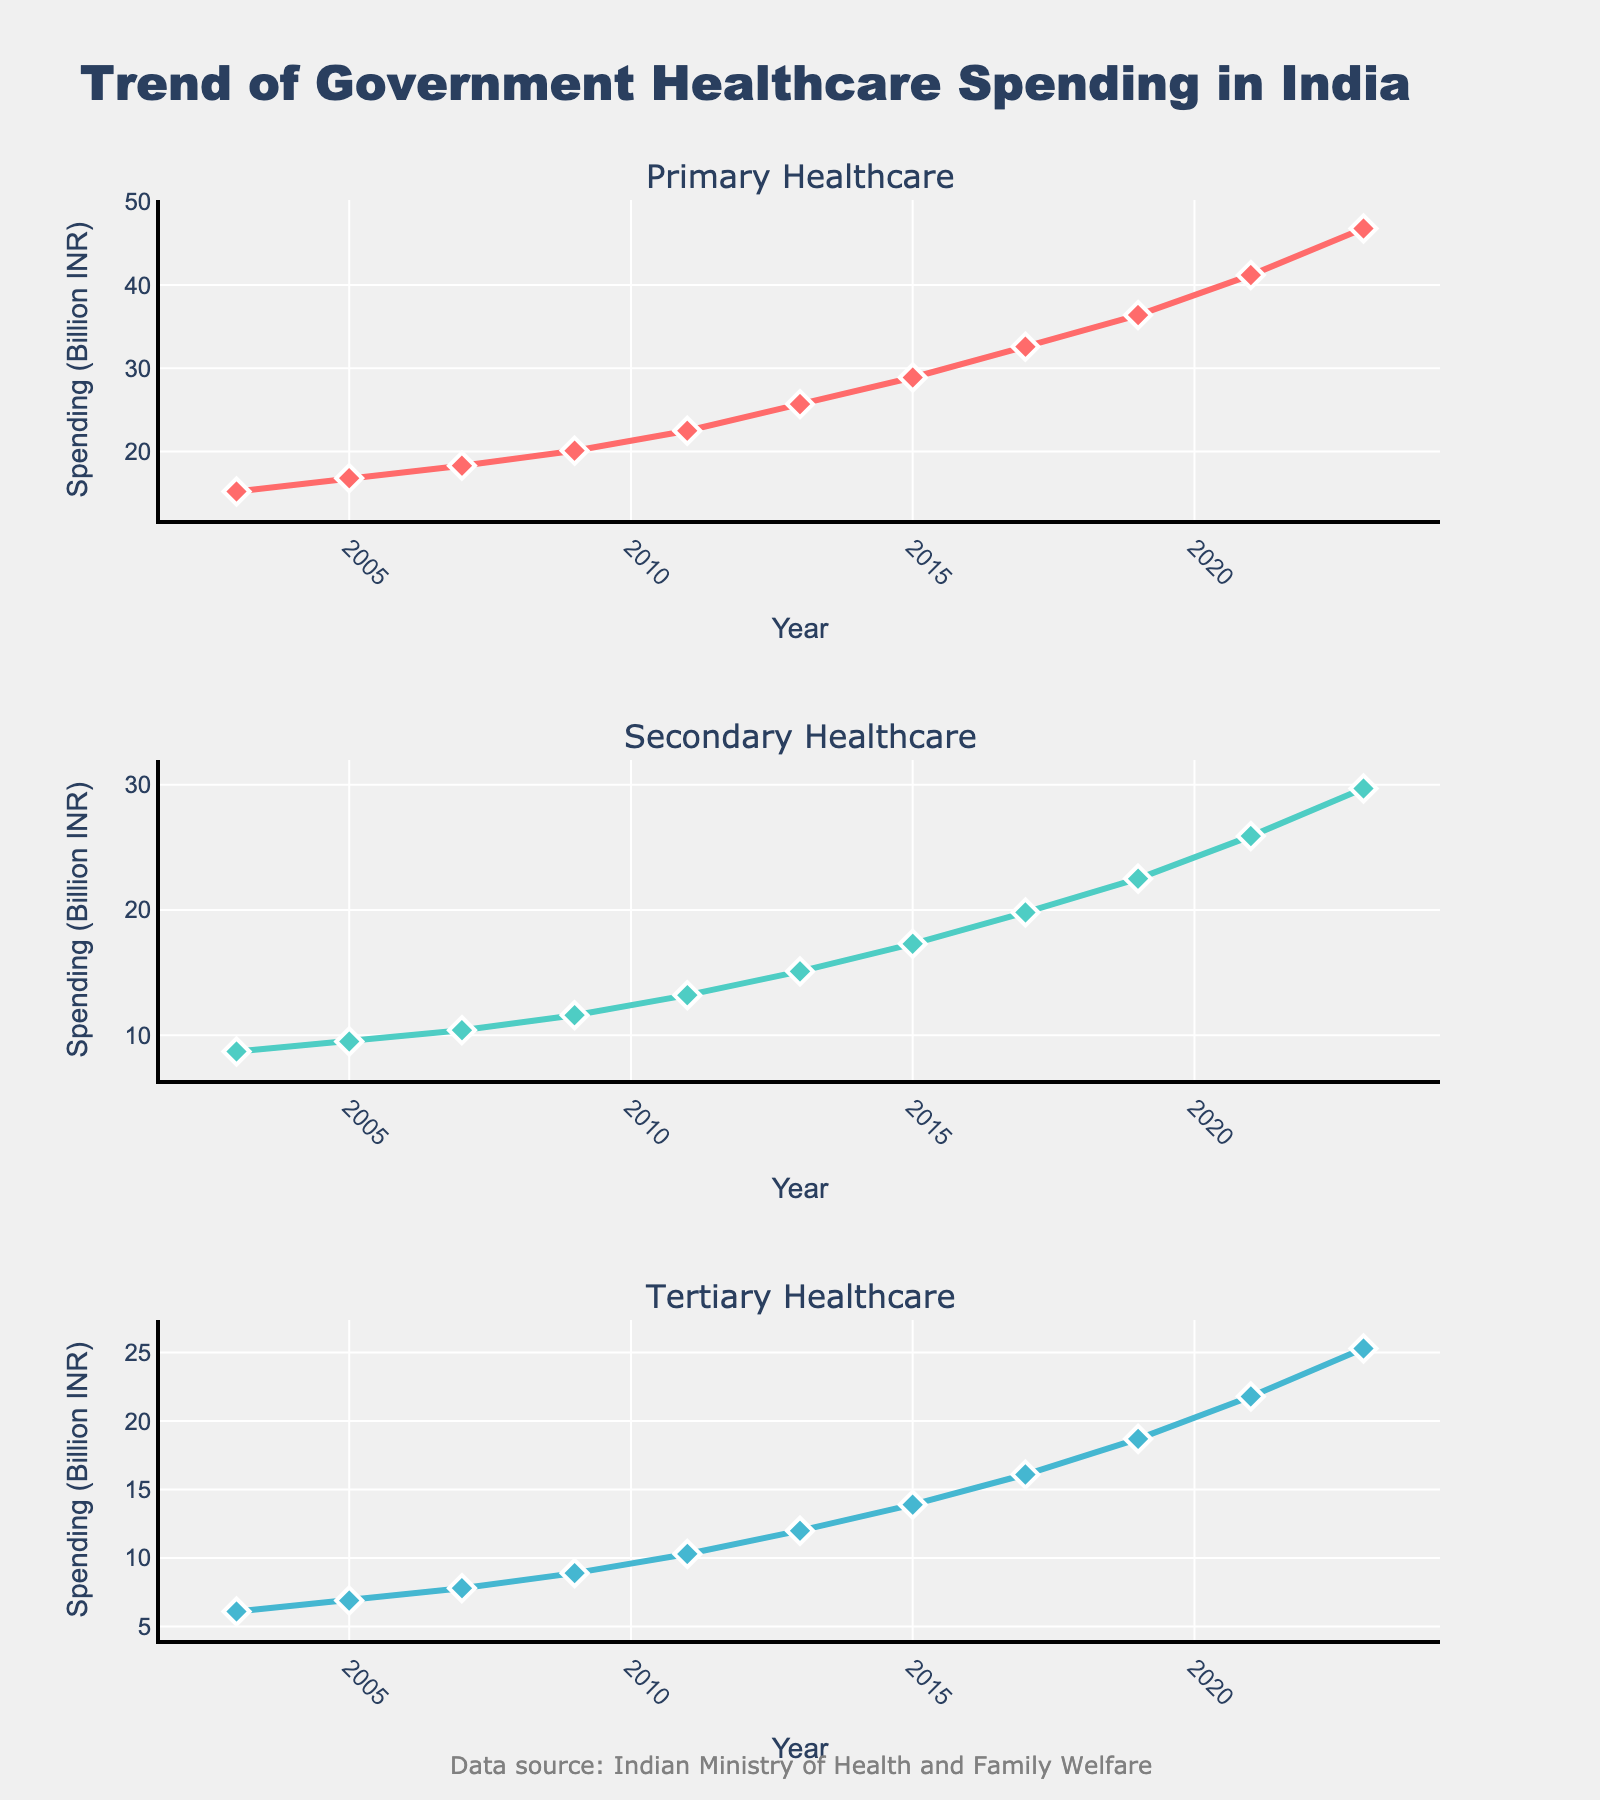Which healthcare sector had the highest spending in 2023? In the subplot for 2023, the "Primary Healthcare" sector shows the highest spending value among the three sectors.
Answer: Primary Healthcare What is the title of the figure? The title of the figure is displayed prominently at the top of the plot.
Answer: Trend of Government Healthcare Spending in India Between 2003 and 2023, by how much did the spending on Secondary Healthcare increase? To find the increase, subtract the spending in 2003 from the spending in 2023 for Secondary Healthcare: 29.7 - 8.7 = 21.
Answer: 21 (Billion INR) Which year shows the sharpest increase in spending across all healthcare sectors? To identify the sharpest increase, observe the slopes of the lines across all three healthcare sectors. The years 2019 to 2021 show a notable increase for all sectors.
Answer: 2019 to 2021 How does the trend of Tertiary Healthcare spending compare to that of Primary Healthcare over the 20 years? The plot shows that both have an upward trend; however, Primary Healthcare increases more steeply compared to Tertiary Healthcare.
Answer: Primary Healthcare increased more steeply What are the colors used for the lines representing the healthcare sectors, and which sector does each color represent? By looking at the lines, the colors are pink, green, and blue for Primary, Secondary, and Tertiary Healthcare, respectively.
Answer: Pink: Primary Healthcare; Green: Secondary Healthcare; Blue: Tertiary Healthcare What is the average government spending on Primary Healthcare over the 20 years? Calculate the average by summing the spending values for Primary Healthcare from 2003 to 2023 and dividing by the number of years. The sum is (15.2 + 16.8 + 18.3 + 20.1 + 22.5 + 25.7 + 28.9 + 32.6 + 36.4 + 41.2 + 46.8) = 304.5. The average is 304.5 / 11 ≈ 27.68.
Answer: 27.68 (Billion INR) Which healthcare sector had the closest spending values between 2003 and 2005? Comparing all sectors between 2003 and 2005, the spending values for the Secondary Healthcare sector increased from 8.7 to 9.5, a difference of 0.8, which is smaller compared to the other sectors.
Answer: Secondary Healthcare By what factor has the spending on Tertiary Healthcare increased from 2003 to 2023? Divide the spending in 2023 by the spending in 2003 for Tertiary Healthcare: 25.3 / 6.1 ≈ 4.15.
Answer: 4.15 Which year had the smallest spending on Primary Healthcare? By observing the Primary Healthcare subplot, the value in 2003 is the smallest.
Answer: 2003 